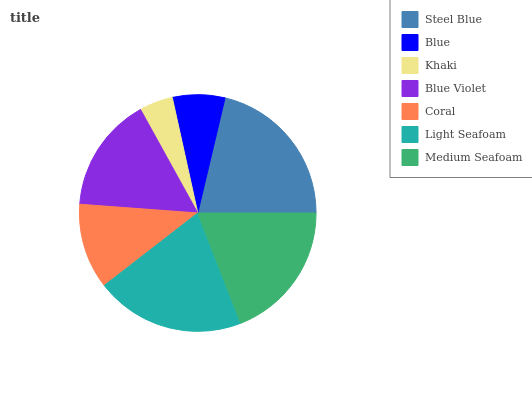Is Khaki the minimum?
Answer yes or no. Yes. Is Steel Blue the maximum?
Answer yes or no. Yes. Is Blue the minimum?
Answer yes or no. No. Is Blue the maximum?
Answer yes or no. No. Is Steel Blue greater than Blue?
Answer yes or no. Yes. Is Blue less than Steel Blue?
Answer yes or no. Yes. Is Blue greater than Steel Blue?
Answer yes or no. No. Is Steel Blue less than Blue?
Answer yes or no. No. Is Blue Violet the high median?
Answer yes or no. Yes. Is Blue Violet the low median?
Answer yes or no. Yes. Is Blue the high median?
Answer yes or no. No. Is Khaki the low median?
Answer yes or no. No. 